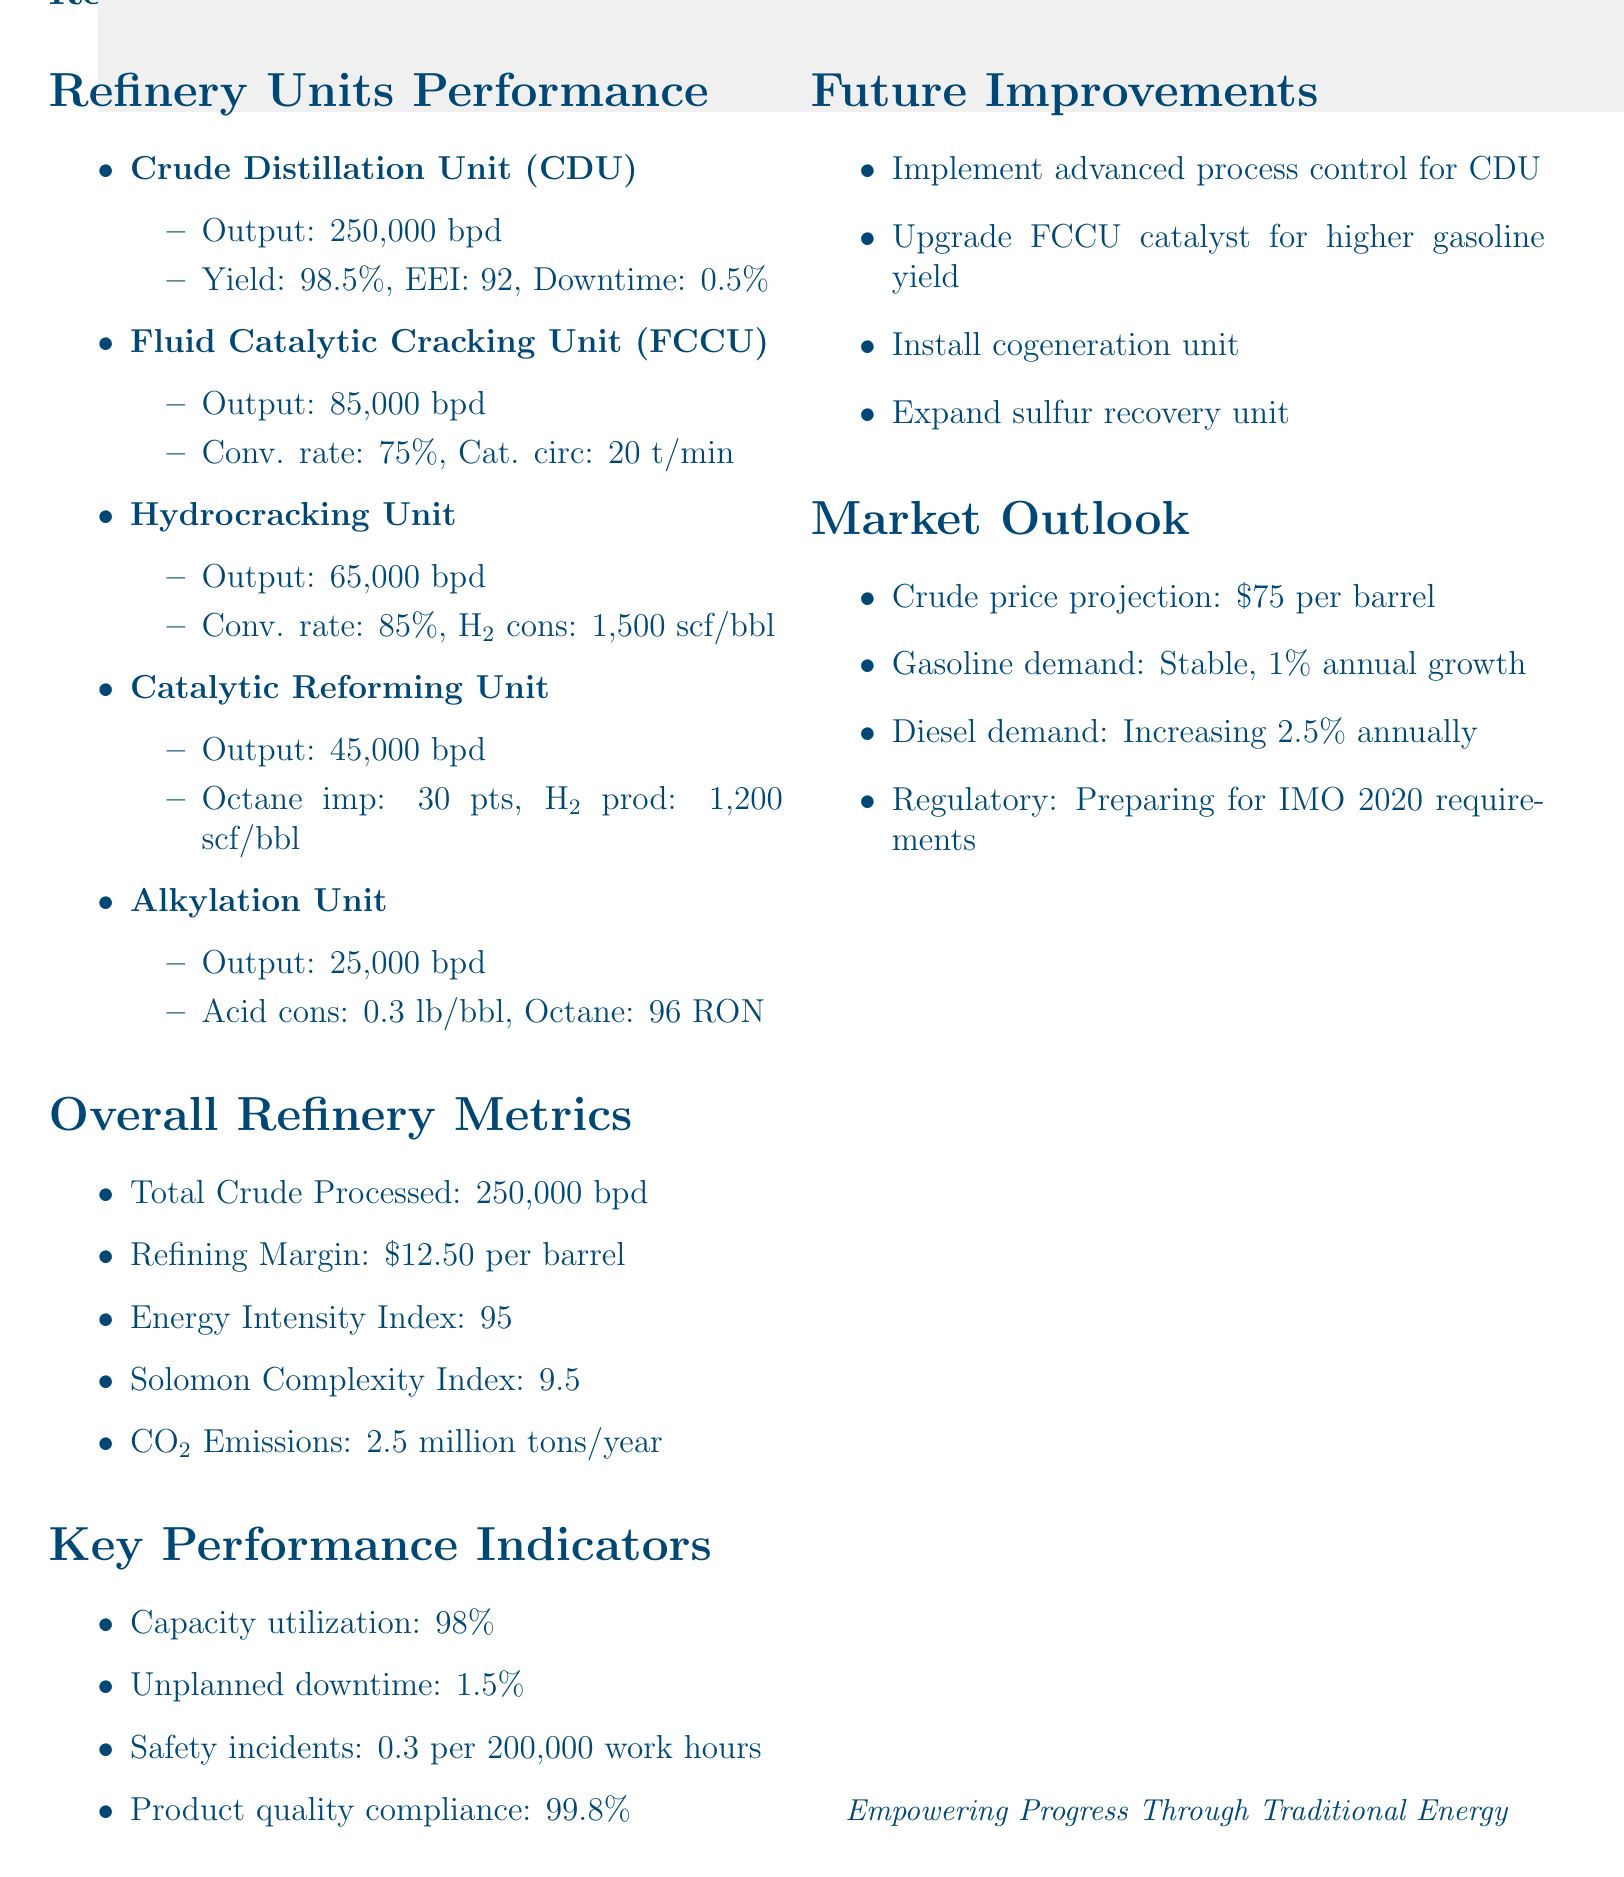What is the daily output of the Crude Distillation Unit? The daily output for the CDU is specified in the document as 250,000 barrels per day.
Answer: 250,000 barrels per day What is the refining margin? The refining margin represents the profit from refining crude oil and is stated as $12.50 per barrel in the document.
Answer: $12.50 per barrel What is the energy efficiency index of the Crude Distillation Unit? The energy efficiency index is a metric for assessing the efficiency of the CDU, reported as 92 in the document.
Answer: 92 Which refinery unit has the highest conversion rate? The Hydrocracking Unit has the highest conversion rate reported in the document, which is 85%.
Answer: Hydrocracking Unit What is the projected price of crude oil? The document mentions a crude price projection of $75 per barrel.
Answer: $75 per barrel What is the safety incident rate per 200,000 work hours? The safety incident rate is detailed as 0.3 per 200,000 work hours in the key performance indicators section.
Answer: 0.3 What improvement is proposed for the FCCU? The document suggests upgrading the FCCU catalyst to increase gasoline yield as a future improvement.
Answer: Upgrade FCCU catalyst How much hydrogen is consumed by the Hydrocracking Unit per barrel? The hydrogen consumption for the Hydrocracking Unit is noted as 1,500 scf per barrel in the efficiency metrics.
Answer: 1,500 scf/bbl What is the CO2 emissions figure for the refinery? The CO2 emissions are reported as 2.5 million tons per year in the overall refinery metrics.
Answer: 2.5 million tons per year 